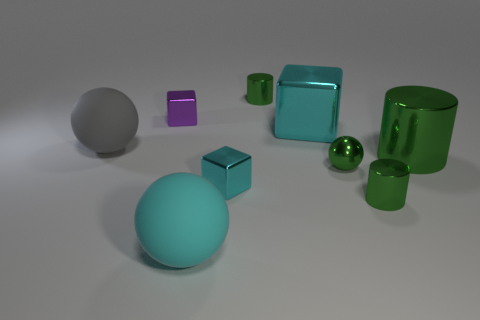What is the texture of the largest sphere, and how does it compare to the textures of the other objects? The largest sphere has a matte, non-reflective surface which contrasts with the shiny, polished surfaces of many other objects in the image, like the smaller green spheres and the cylinder. 